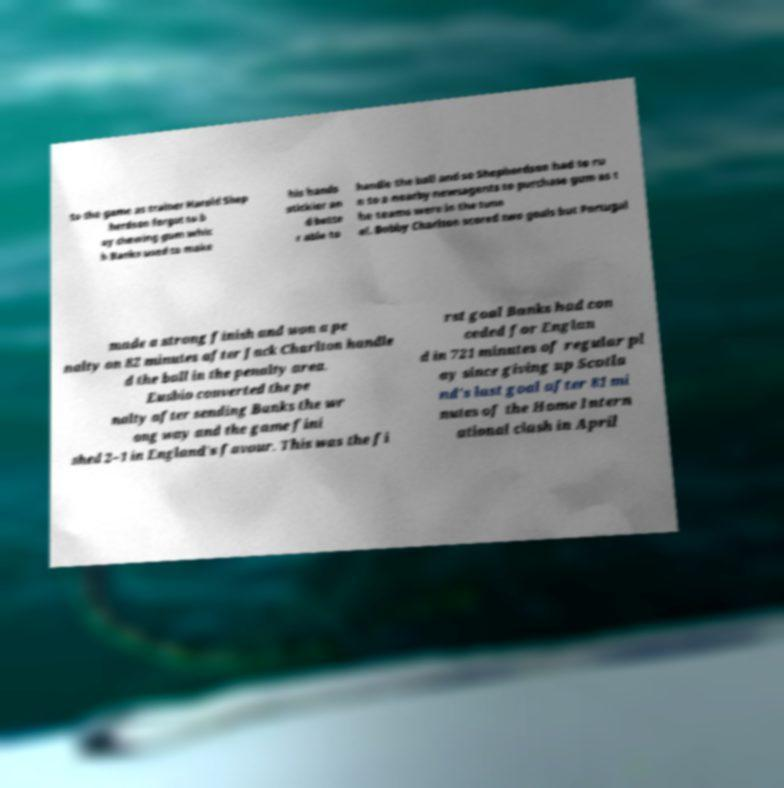Please identify and transcribe the text found in this image. to the game as trainer Harold Shep herdson forgot to b uy chewing gum whic h Banks used to make his hands stickier an d bette r able to handle the ball and so Shepherdson had to ru n to a nearby newsagents to purchase gum as t he teams were in the tunn el. Bobby Charlton scored two goals but Portugal made a strong finish and won a pe nalty on 82 minutes after Jack Charlton handle d the ball in the penalty area. Eusbio converted the pe nalty after sending Banks the wr ong way and the game fini shed 2–1 in England's favour. This was the fi rst goal Banks had con ceded for Englan d in 721 minutes of regular pl ay since giving up Scotla nd's last goal after 81 mi nutes of the Home Intern ational clash in April 